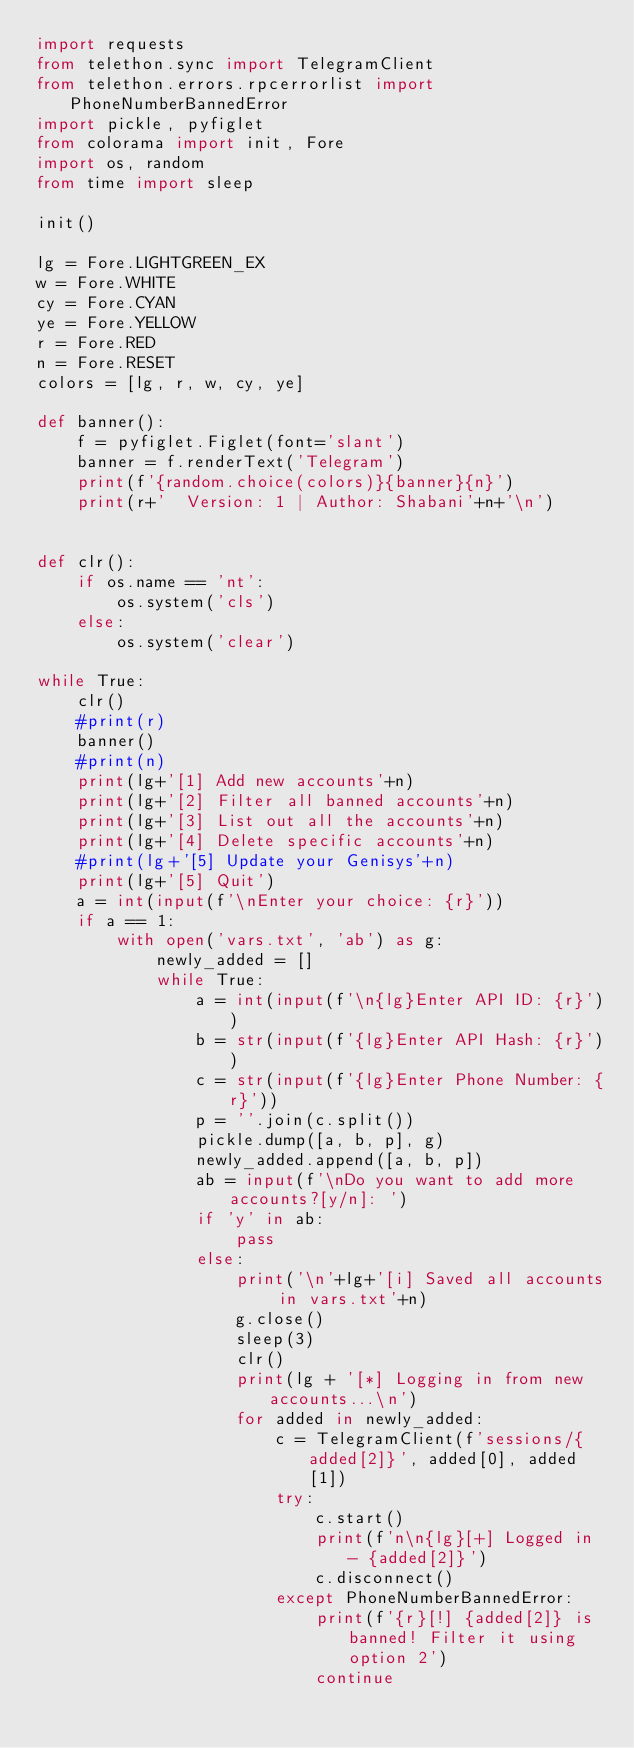Convert code to text. <code><loc_0><loc_0><loc_500><loc_500><_Python_>import requests
from telethon.sync import TelegramClient
from telethon.errors.rpcerrorlist import PhoneNumberBannedError
import pickle, pyfiglet
from colorama import init, Fore
import os, random
from time import sleep

init()

lg = Fore.LIGHTGREEN_EX
w = Fore.WHITE
cy = Fore.CYAN
ye = Fore.YELLOW
r = Fore.RED
n = Fore.RESET
colors = [lg, r, w, cy, ye]

def banner():
    f = pyfiglet.Figlet(font='slant')
    banner = f.renderText('Telegram')
    print(f'{random.choice(colors)}{banner}{n}')
    print(r+'  Version: 1 | Author: Shabani'+n+'\n')


def clr():
    if os.name == 'nt':
        os.system('cls')
    else:
        os.system('clear')

while True:
    clr()
    #print(r)
    banner()
    #print(n)
    print(lg+'[1] Add new accounts'+n)
    print(lg+'[2] Filter all banned accounts'+n)
    print(lg+'[3] List out all the accounts'+n)
    print(lg+'[4] Delete specific accounts'+n)
    #print(lg+'[5] Update your Genisys'+n)
    print(lg+'[5] Quit')
    a = int(input(f'\nEnter your choice: {r}'))
    if a == 1:
        with open('vars.txt', 'ab') as g:
            newly_added = []
            while True:
                a = int(input(f'\n{lg}Enter API ID: {r}'))
                b = str(input(f'{lg}Enter API Hash: {r}'))
                c = str(input(f'{lg}Enter Phone Number: {r}'))
                p = ''.join(c.split())
                pickle.dump([a, b, p], g)
                newly_added.append([a, b, p])
                ab = input(f'\nDo you want to add more accounts?[y/n]: ')
                if 'y' in ab:
                    pass
                else:
                    print('\n'+lg+'[i] Saved all accounts in vars.txt'+n)
                    g.close()
                    sleep(3)
                    clr()
                    print(lg + '[*] Logging in from new accounts...\n')
                    for added in newly_added:
                        c = TelegramClient(f'sessions/{added[2]}', added[0], added[1])
                        try:
                            c.start()
                            print(f'n\n{lg}[+] Logged in - {added[2]}')
                            c.disconnect()
                        except PhoneNumberBannedError:
                            print(f'{r}[!] {added[2]} is banned! Filter it using option 2')
                            continue</code> 